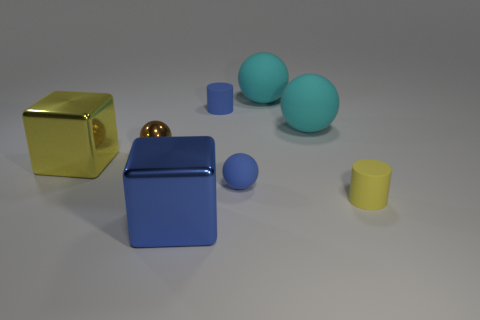What is the material of the tiny blue thing that is the same shape as the brown thing?
Your answer should be very brief. Rubber. Is the material of the blue ball the same as the big block that is to the right of the tiny brown metallic sphere?
Your response must be concise. No. There is a small object on the right side of the small blue thing that is to the right of the small blue rubber cylinder; are there any blue blocks that are behind it?
Offer a very short reply. No. What is the shape of the metal object that is the same size as the blue matte sphere?
Provide a short and direct response. Sphere. Is the size of the matte ball in front of the big yellow shiny thing the same as the yellow thing that is right of the big blue cube?
Your response must be concise. Yes. What number of yellow rubber things are there?
Ensure brevity in your answer.  1. There is a sphere that is left of the large block in front of the yellow cube that is left of the blue cylinder; how big is it?
Keep it short and to the point. Small. There is a blue ball; how many blue cubes are to the right of it?
Offer a terse response. 0. Are there an equal number of tiny balls right of the blue metallic thing and tiny metallic spheres?
Provide a short and direct response. Yes. How many objects are big rubber things or blue metallic objects?
Your answer should be very brief. 3. 